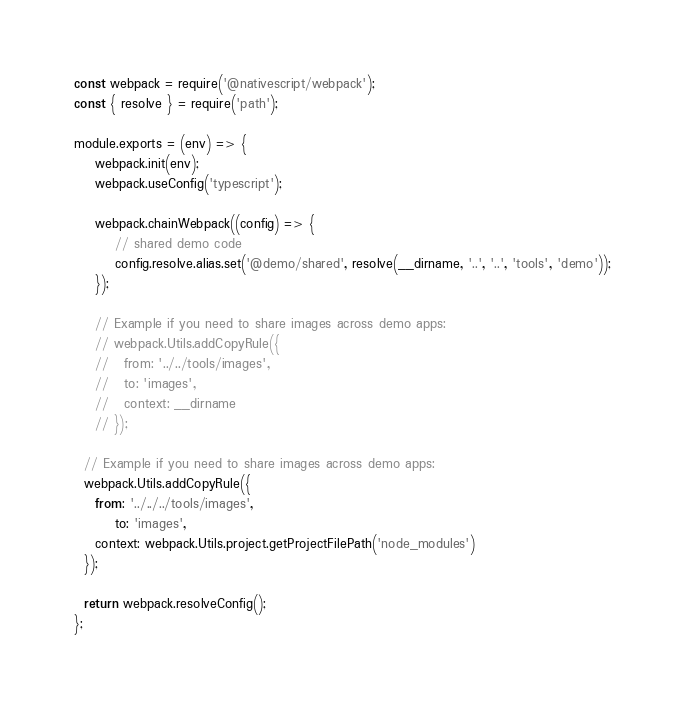Convert code to text. <code><loc_0><loc_0><loc_500><loc_500><_JavaScript_>const webpack = require('@nativescript/webpack');
const { resolve } = require('path');

module.exports = (env) => {
	webpack.init(env);
	webpack.useConfig('typescript');

	webpack.chainWebpack((config) => {
		// shared demo code
		config.resolve.alias.set('@demo/shared', resolve(__dirname, '..', '..', 'tools', 'demo'));
	});

	// Example if you need to share images across demo apps:
	// webpack.Utils.addCopyRule({
	//   from: '../../tools/images',
	// 	 to: 'images',
	//   context: __dirname
	// });

  // Example if you need to share images across demo apps:
  webpack.Utils.addCopyRule({
    from: '../../../tools/images', 
		to: 'images',
    context: webpack.Utils.project.getProjectFilePath('node_modules')
  });

  return webpack.resolveConfig();
};
</code> 